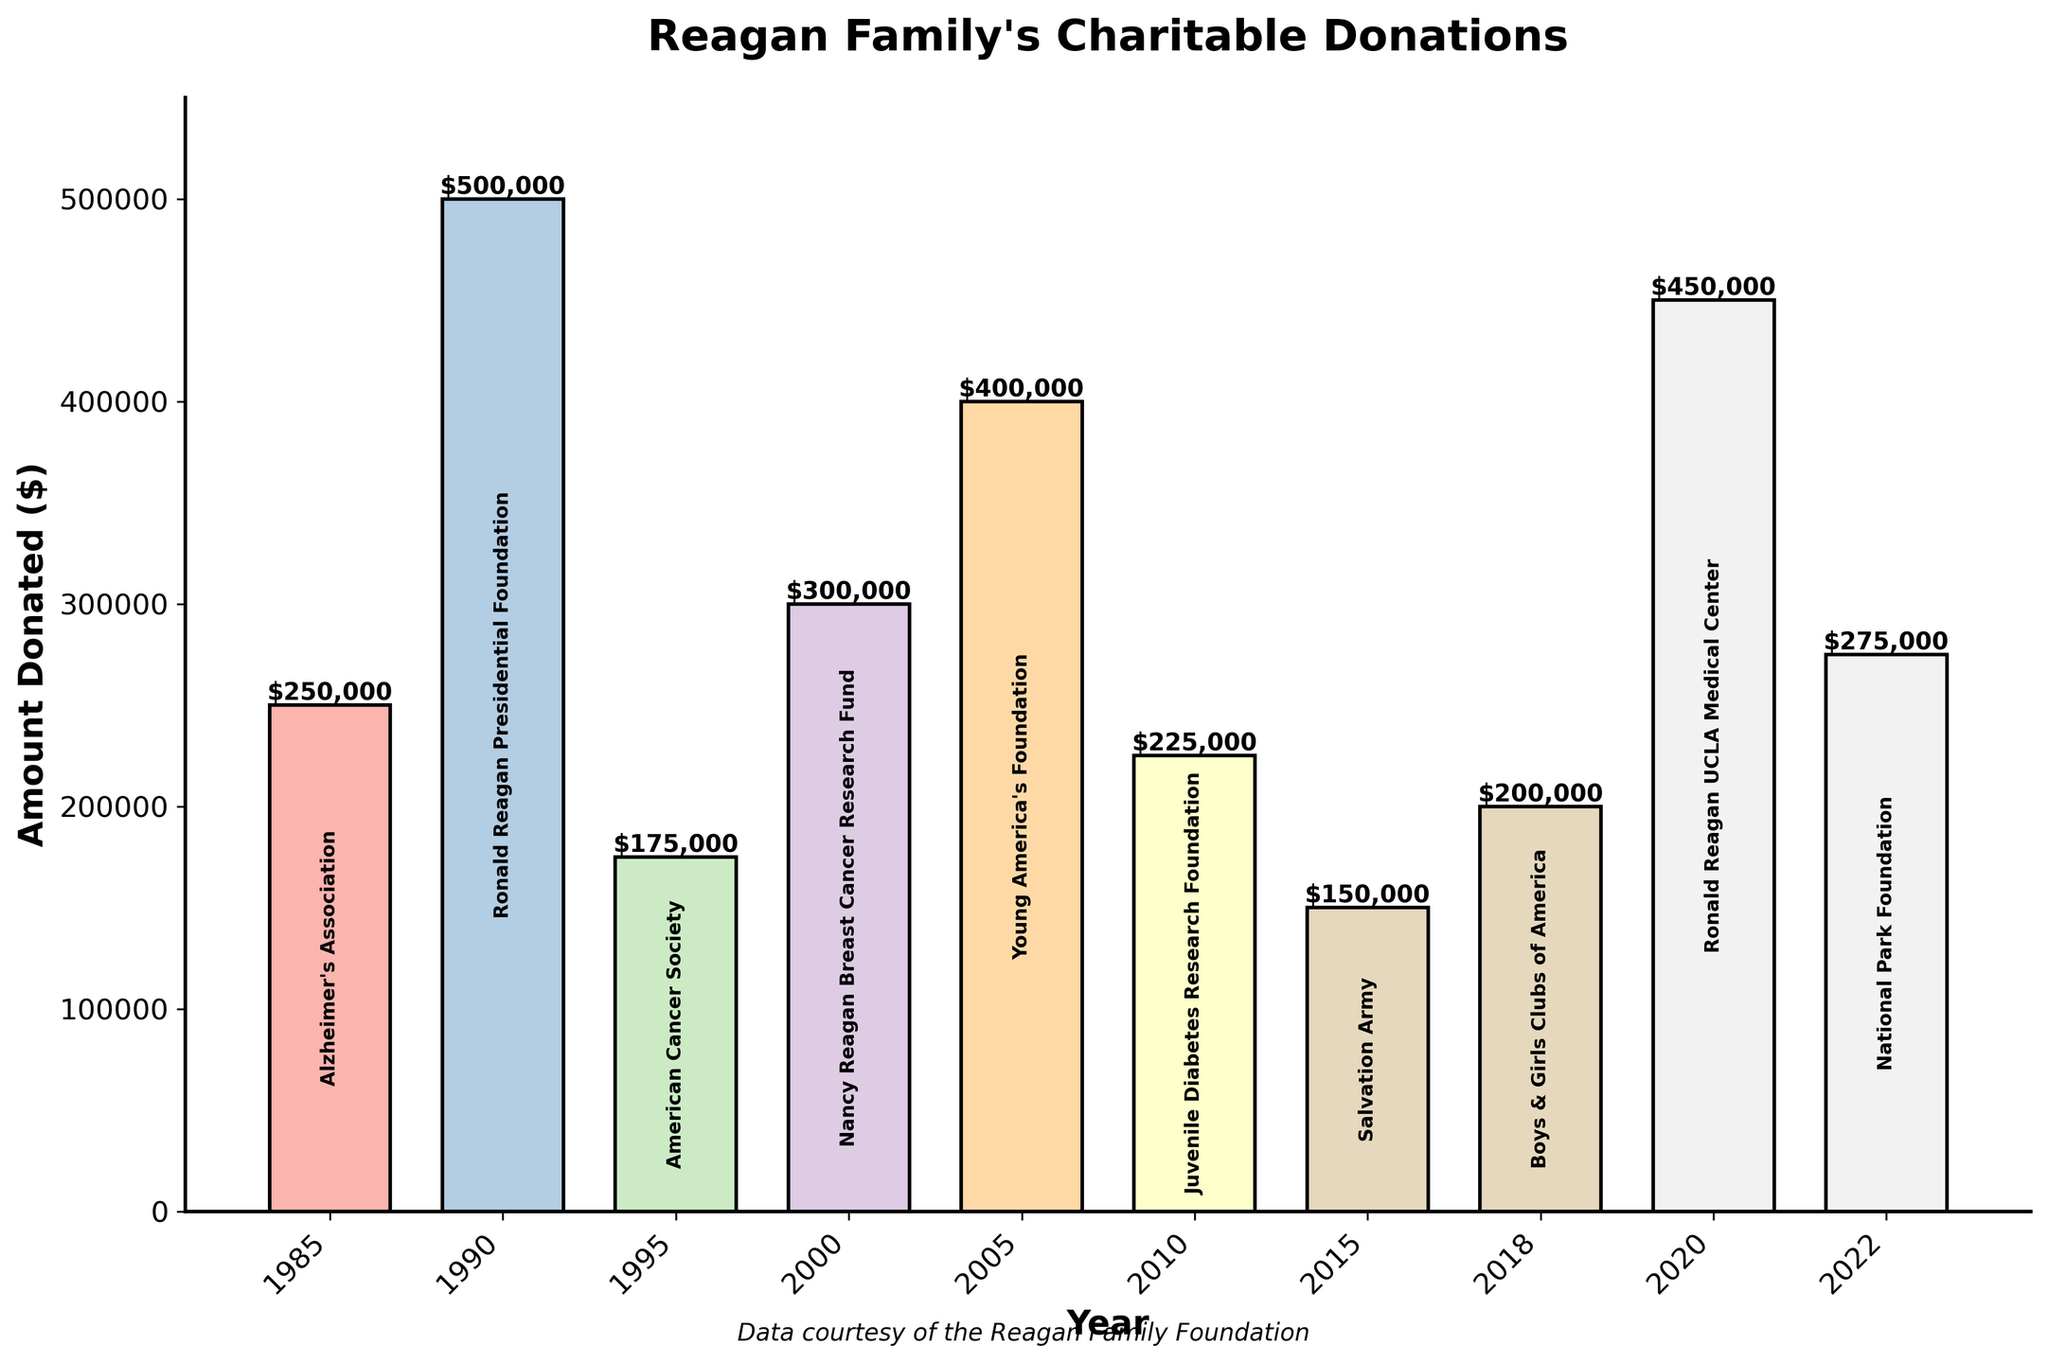What year did the Reagan family donate the largest amount? Look at the bar heights and find the tallest one. The year at the base of this bar is 1990. The amount is $500,000.
Answer: 1990 How much more did the Reagan family donate in 2020 compared to 2015? In 2020, the amount was $450,000. In 2015, it was $150,000. Subtract the smaller amount from the larger amount: $450,000 - $150,000 = $300,000.
Answer: $300,000 What is the average donation amount over the years? Add up all the donation values: 250,000 + 500,000 + 175,000 + 300,000 + 400,000 + 225,000 + 150,000 + 200,000 + 450,000 + 275,000 = 2,925,000. Divide by the number of years (10): 2,925,000 / 10 = $292,500.
Answer: $292,500 Which recipient received the donation in 2000? Look at the label inside the bar for the year 2000. It reads "Nancy Reagan Breast Cancer Research Fund."
Answer: Nancy Reagan Breast Cancer Research Fund Are there more donations made before or after the year 2000? Count the bars before 2000 (1985, 1990, 1995) which is 3, and after 2000 (2000, 2005, 2010, 2015, 2018, 2020, 2022) which is 7. There are more donations made after the year 2000.
Answer: After What is the combined total amount donated in the 1980s and 1990s? Add the amounts from 1985, 1990, and 1995: 250,000 + 500,000 + 175,000 = 925,000.
Answer: $925,000 Which two consecutive years saw the smallest difference in donation amounts? Compare the differences between every consecutive pair:
1990 - 1985 = 250,000
1995 - 1990 = 325,000
2000 - 1995 = 125,000
2005 - 2000 = 100,000
2010 - 2005 = 175,000
2015 - 2010 = 75,000
2018 - 2015 = 50,000
2020 - 2018 = 250,000
2022 - 2020 = 175,000
The smallest difference is between 2015 and 2018 at $50,000.
Answer: 2015 and 2018 What is the total amount donated by the Reagan family from 2005 to 2020? Sum the donations from 2005, 2010, 2015, 2018, and 2020: 400,000 + 225,000 + 150,000 + 200,000 + 450,000 = 1,425,000.
Answer: $1,425,000 Compare the donations in 1995 and 2010 by their amounts and identify which was greater. The donation in 1995 was $175,000 and in 2010 it was $225,000. Since $225,000 is greater than $175,000, the 2010 donation was greater.
Answer: 2010 